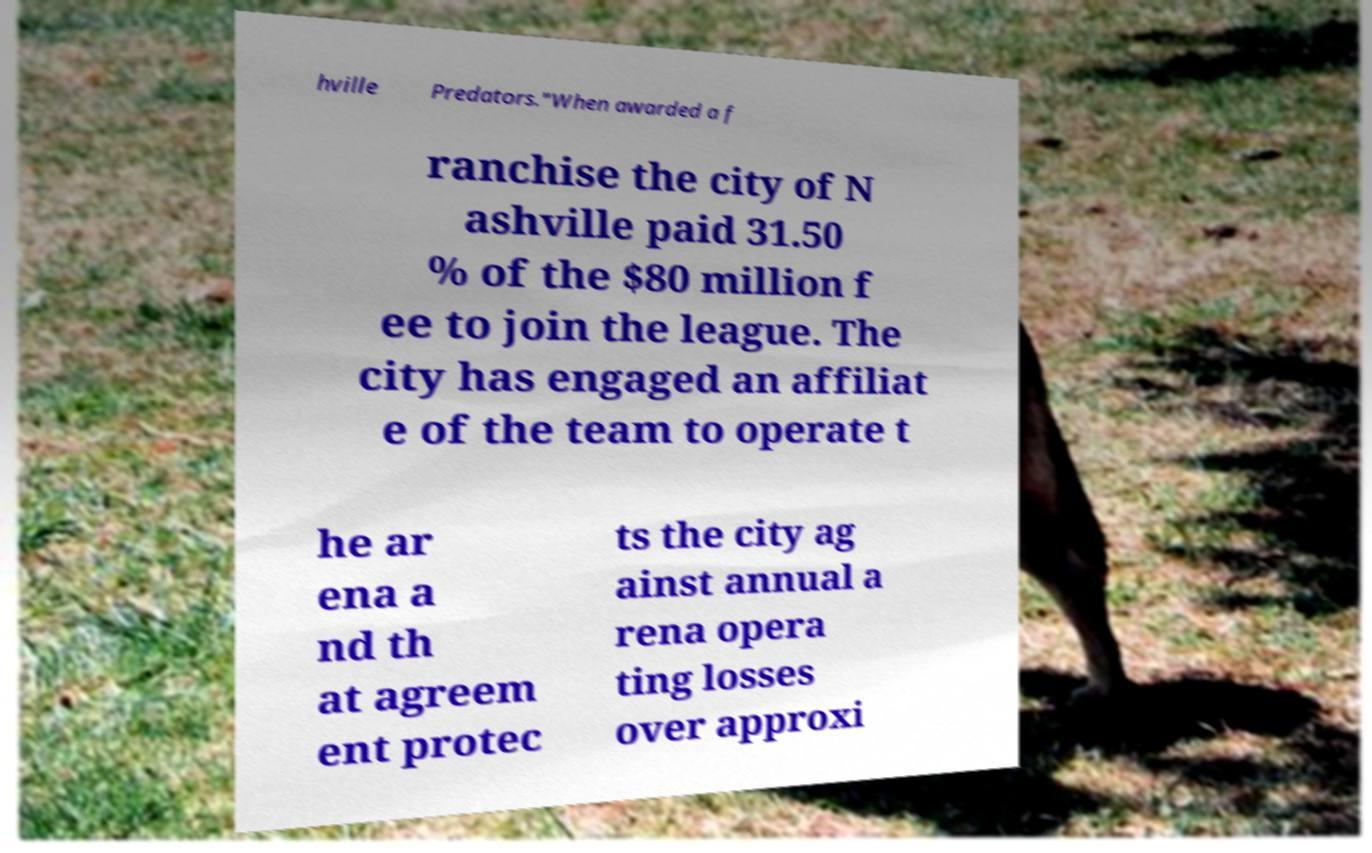Could you extract and type out the text from this image? hville Predators."When awarded a f ranchise the city of N ashville paid 31.50 % of the $80 million f ee to join the league. The city has engaged an affiliat e of the team to operate t he ar ena a nd th at agreem ent protec ts the city ag ainst annual a rena opera ting losses over approxi 